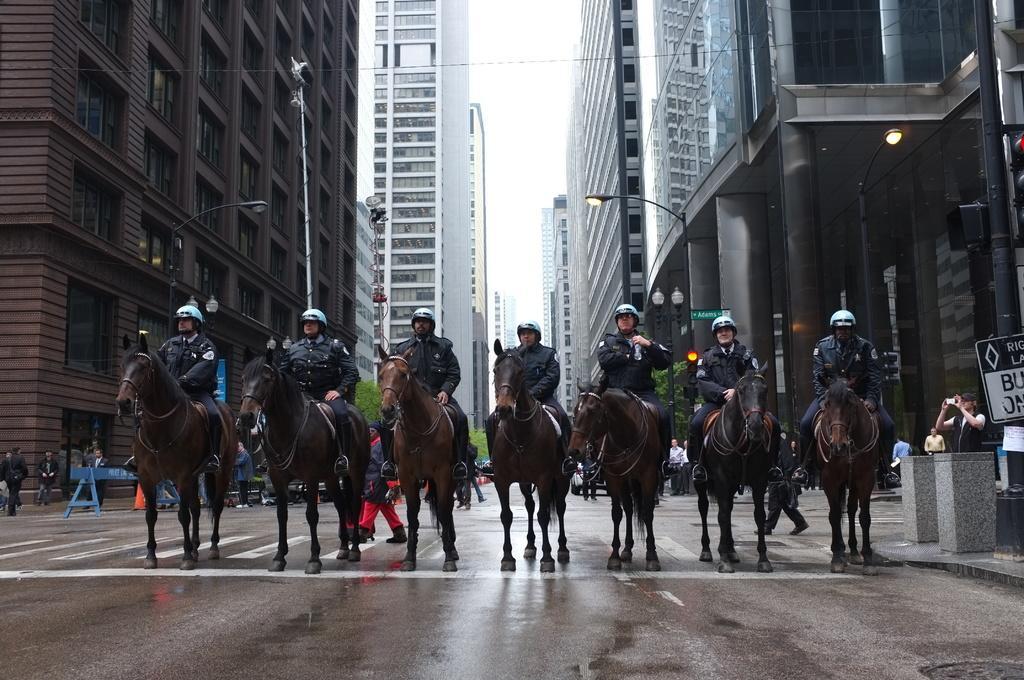Could you give a brief overview of what you see in this image? In this picture I can see few people are sitting on the horses which is on the road, around we can see few people on the road, sides of the road we can see some buildings. 